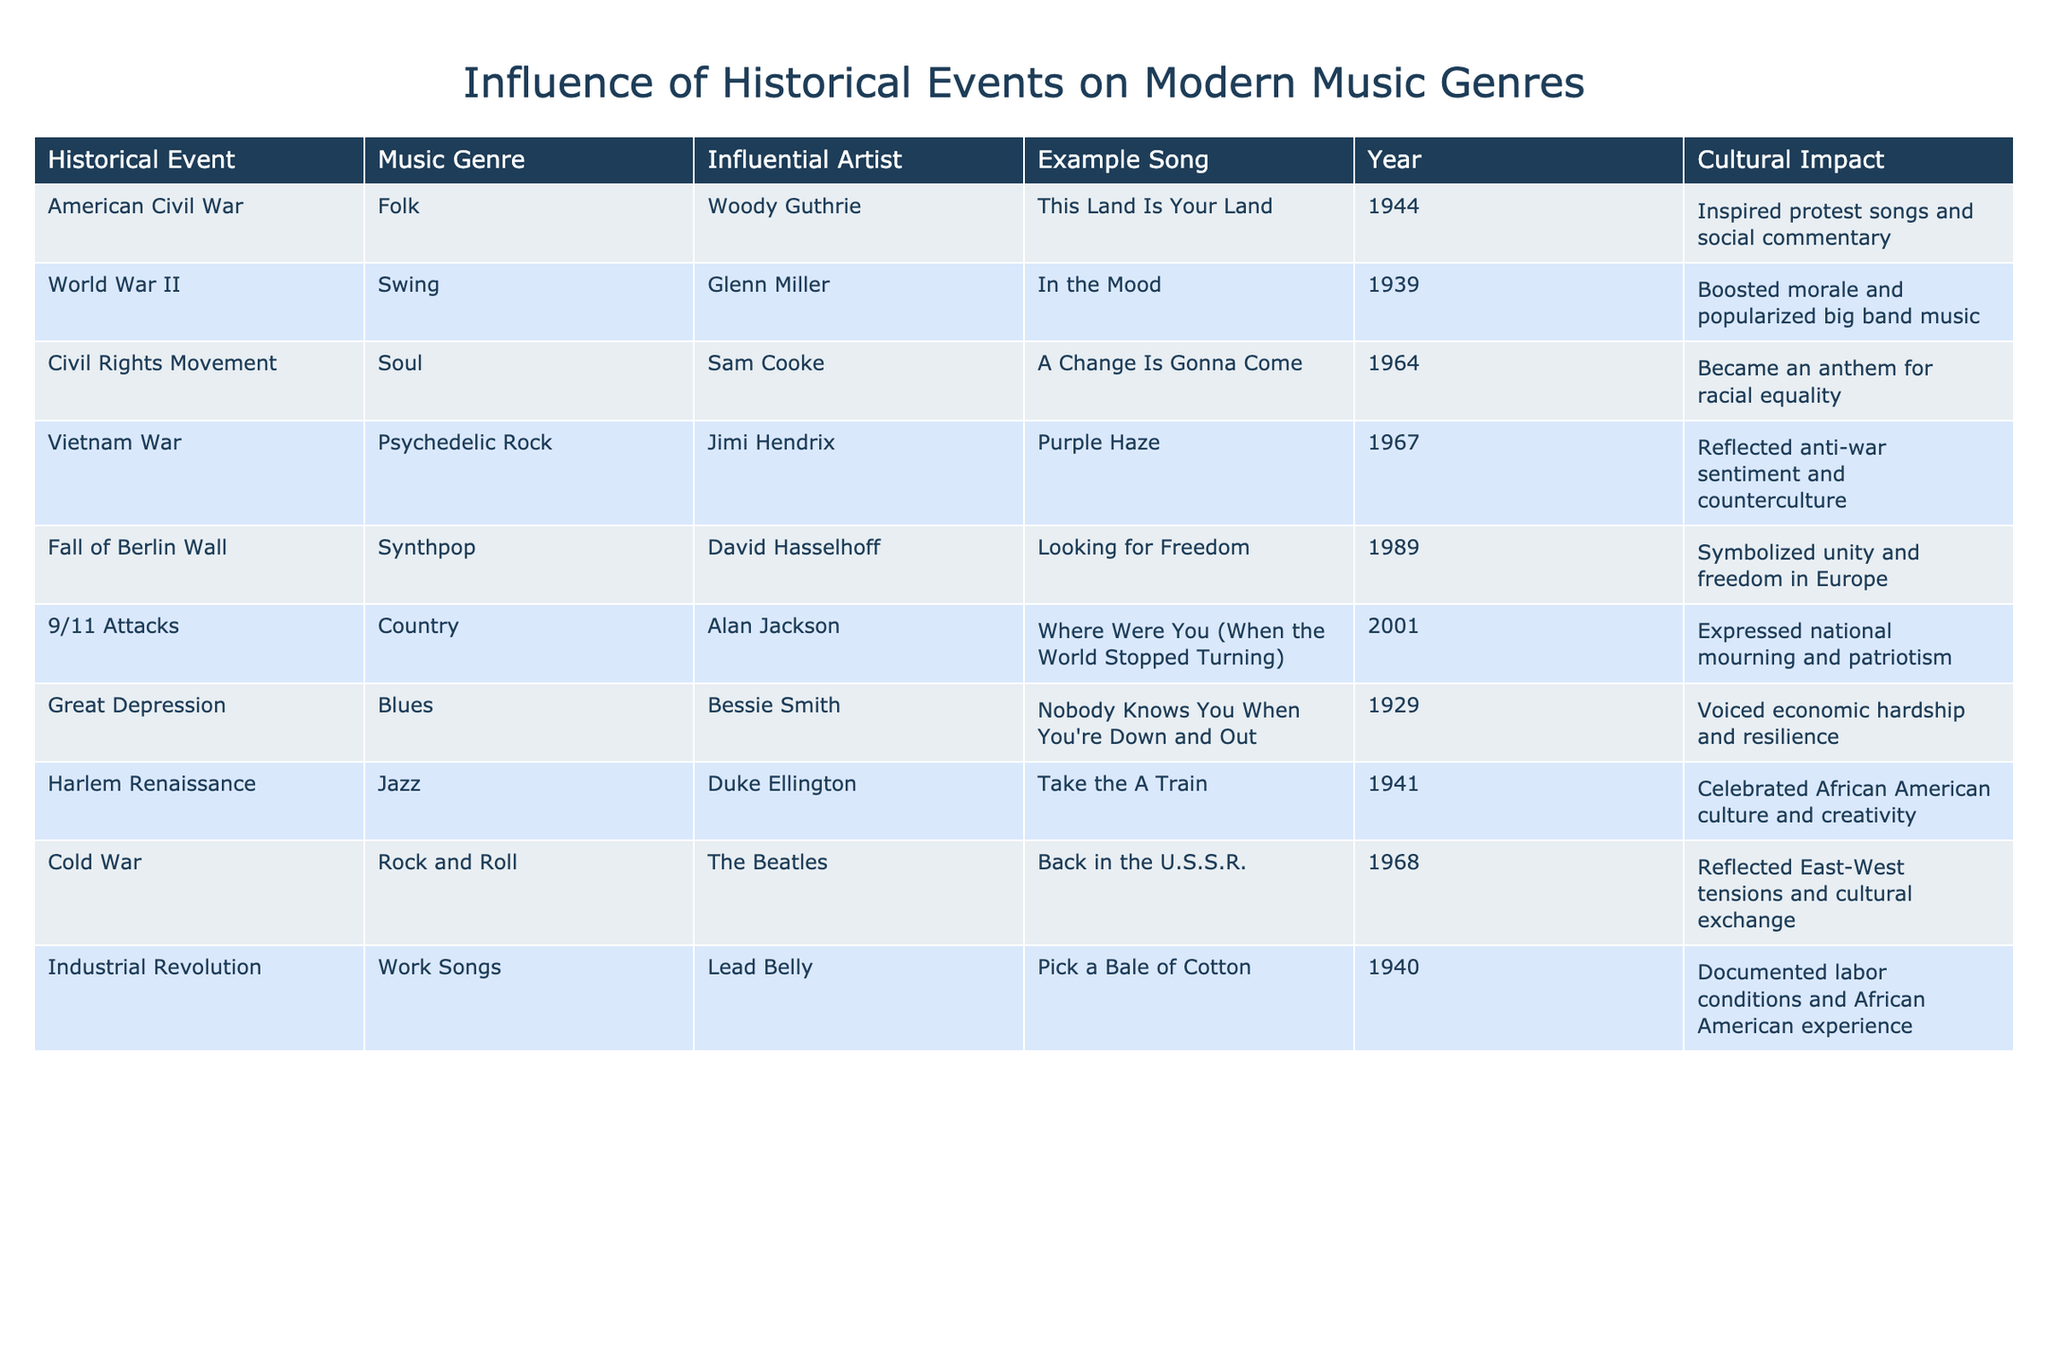What music genre is associated with the Civil Rights Movement? The table indicates that the music genre associated with the Civil Rights Movement is Soul. This is found in the row where 'Civil Rights Movement' is listed under 'Historical Event,' which corresponds to 'Soul' in the 'Music Genre' column.
Answer: Soul Which influential artist is linked to the American Civil War? According to the table, Woody Guthrie is the influential artist linked to the American Civil War. This can be found in the row that lists 'American Civil War' under 'Historical Event,' with 'Woody Guthrie' in the 'Influential Artist' column.
Answer: Woody Guthrie Was the song "In the Mood" released before the song "A Change Is Gonna Come"? The table shows that "In the Mood" was released in 1939 and "A Change Is Gonna Come" in 1964. Since 1939 is earlier than 1964, the answer is yes.
Answer: Yes What is the cultural impact of the Fall of the Berlin Wall on music? The table states that the cultural impact of the Fall of the Berlin Wall was that it symbolized unity and freedom in Europe. This explanation is summarized in the corresponding row where the event and its impact are described.
Answer: Symbolized unity and freedom in Europe Which two musical genres emerged from events related to wars? The genres that emerged from historical events related to wars include Folk from the American Civil War and Psychedelic Rock from the Vietnam War. By reviewing the rows associated with these events, both genres are confirmed.
Answer: Folk and Psychedelic Rock How many years apart were the Great Depression and World War II? The Great Depression occurred in 1929 and World War II started in 1939. To find the difference, we subtract 1929 from 1939, resulting in a 10-year gap.
Answer: 10 years Is "Looking for Freedom" a song by an artist associated with the Cold War? The table notes that "Looking for Freedom" is by David Hasselhoff, linked to the Fall of the Berlin Wall, not the Cold War. Thus, the fact is false as there's no direct association in the table.
Answer: No Which song was released that reflected anti-war sentiment and what is its genre? The song that reflected anti-war sentiment is "Purple Haze," which is categorized under the genre of Psychedelic Rock. This is detailed in the row related to the Vietnam War and corresponds to both the song and its genre.
Answer: Purple Haze, Psychedelic Rock What was the cultural impact of Swing music during World War II? The cultural impact of Swing music, as shown in the table, was that it boosted morale and popularized big band music. This interpretation comes from the specific row regarding World War II, summarizing its impact.
Answer: Boosted morale and popularized big band music 